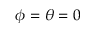Convert formula to latex. <formula><loc_0><loc_0><loc_500><loc_500>\phi = \theta = 0</formula> 